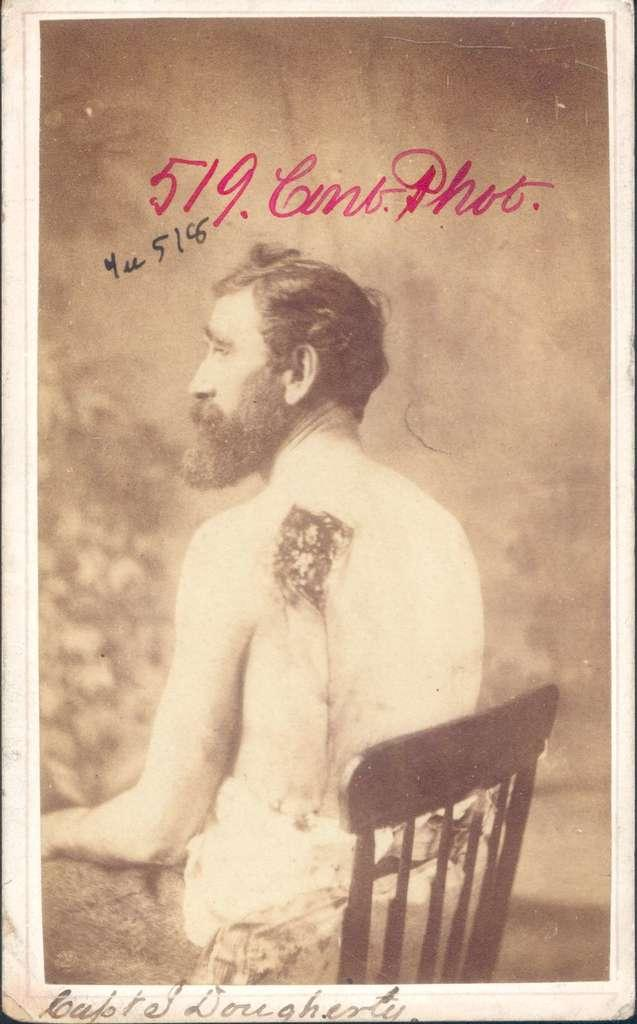What is the main subject of the image? There is a photo in the image. What can be seen in the photo? The photo contains a person sitting on a chair. What type of text is present in the image? There is text at the bottom of the image and text at the top of the image. What type of insect can be seen crawling on the person's shoulder in the image? There is no insect present on the person's shoulder in the image. What emotion does the person in the photo appear to be experiencing? The image does not provide enough information to determine the person's emotions. 